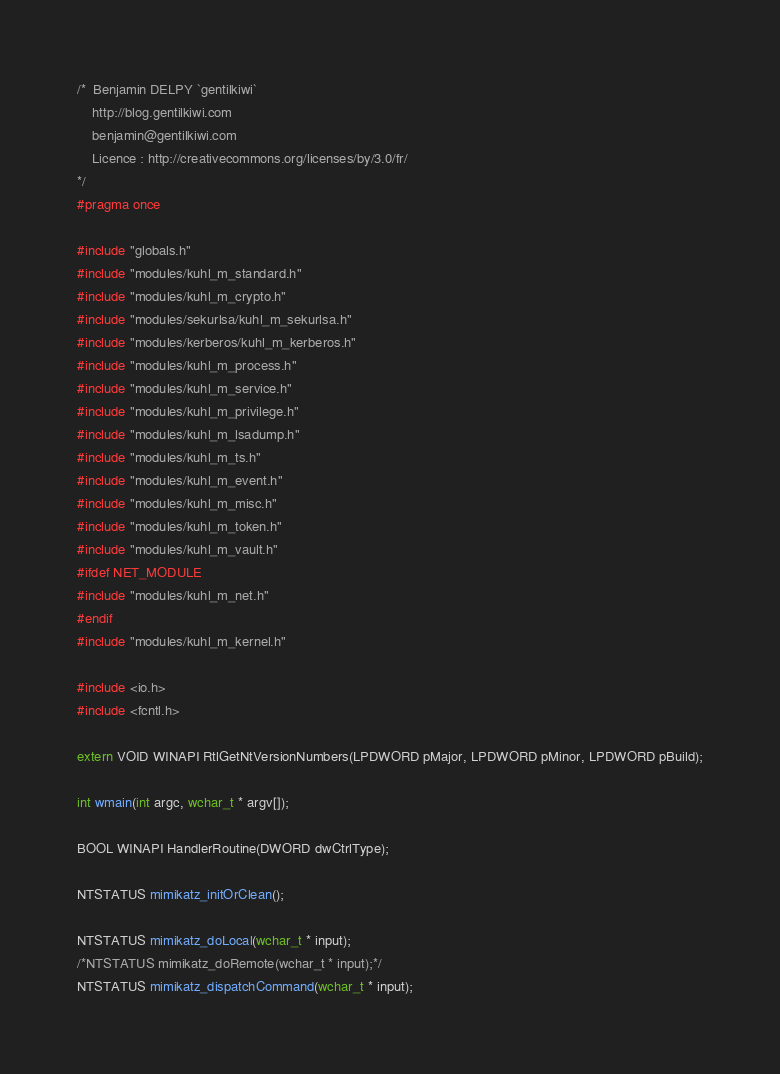<code> <loc_0><loc_0><loc_500><loc_500><_C_>/*	Benjamin DELPY `gentilkiwi`
	http://blog.gentilkiwi.com
	benjamin@gentilkiwi.com
	Licence : http://creativecommons.org/licenses/by/3.0/fr/
*/
#pragma once

#include "globals.h"
#include "modules/kuhl_m_standard.h"
#include "modules/kuhl_m_crypto.h"
#include "modules/sekurlsa/kuhl_m_sekurlsa.h"
#include "modules/kerberos/kuhl_m_kerberos.h"
#include "modules/kuhl_m_process.h"
#include "modules/kuhl_m_service.h"
#include "modules/kuhl_m_privilege.h"
#include "modules/kuhl_m_lsadump.h"
#include "modules/kuhl_m_ts.h"
#include "modules/kuhl_m_event.h"
#include "modules/kuhl_m_misc.h"
#include "modules/kuhl_m_token.h"
#include "modules/kuhl_m_vault.h"
#ifdef NET_MODULE
#include "modules/kuhl_m_net.h"
#endif
#include "modules/kuhl_m_kernel.h"

#include <io.h>
#include <fcntl.h>

extern VOID WINAPI RtlGetNtVersionNumbers(LPDWORD pMajor, LPDWORD pMinor, LPDWORD pBuild);

int wmain(int argc, wchar_t * argv[]);

BOOL WINAPI HandlerRoutine(DWORD dwCtrlType);

NTSTATUS mimikatz_initOrClean();

NTSTATUS mimikatz_doLocal(wchar_t * input);
/*NTSTATUS mimikatz_doRemote(wchar_t * input);*/
NTSTATUS mimikatz_dispatchCommand(wchar_t * input);</code> 